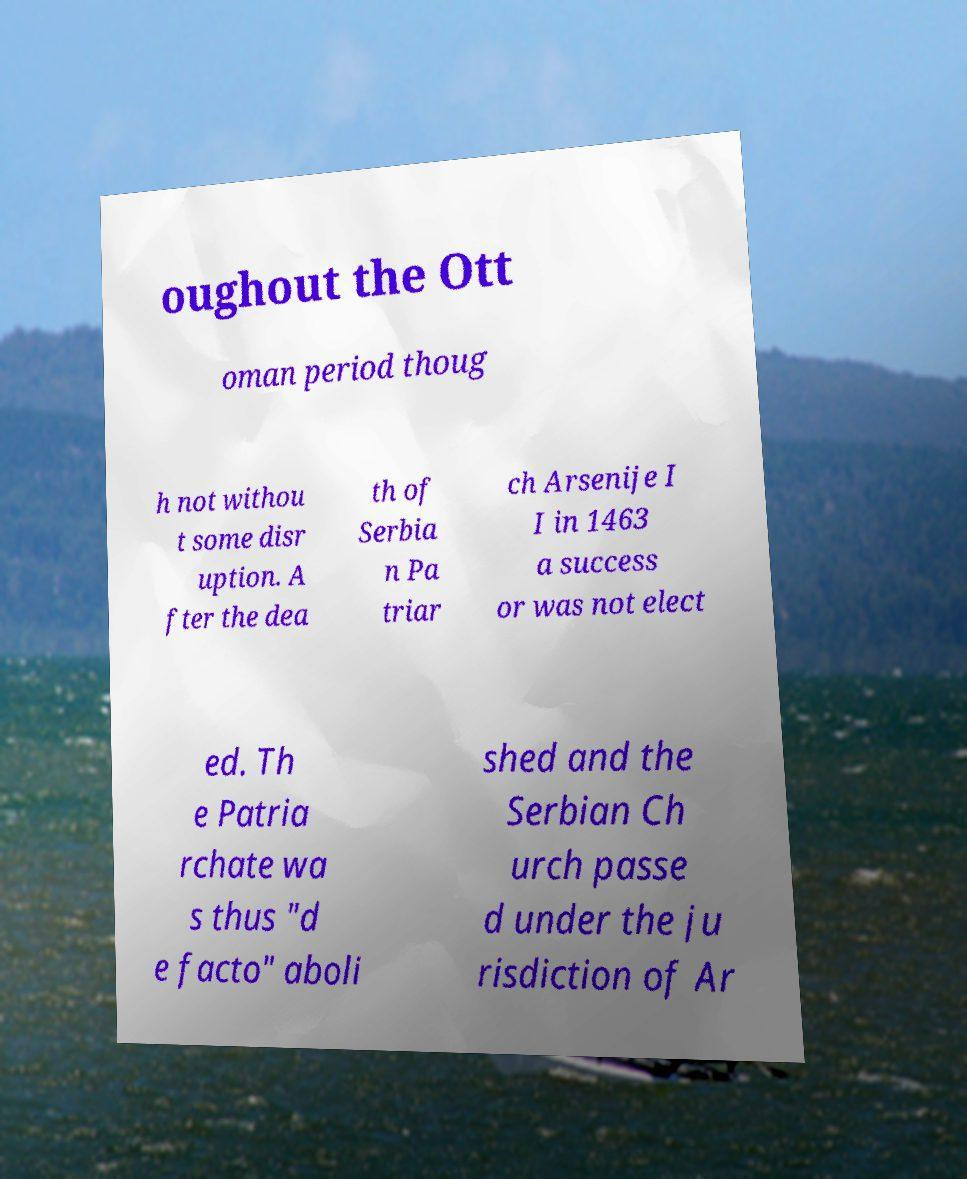Could you assist in decoding the text presented in this image and type it out clearly? oughout the Ott oman period thoug h not withou t some disr uption. A fter the dea th of Serbia n Pa triar ch Arsenije I I in 1463 a success or was not elect ed. Th e Patria rchate wa s thus "d e facto" aboli shed and the Serbian Ch urch passe d under the ju risdiction of Ar 